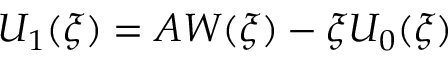<formula> <loc_0><loc_0><loc_500><loc_500>U _ { 1 } ( \xi ) = A W ( \xi ) - \xi U _ { 0 } ( \xi )</formula> 